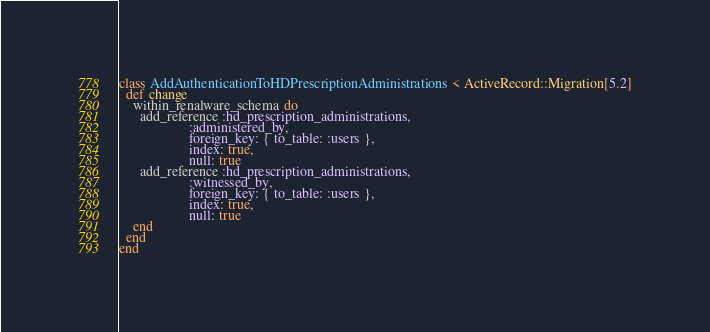<code> <loc_0><loc_0><loc_500><loc_500><_Ruby_>class AddAuthenticationToHDPrescriptionAdministrations < ActiveRecord::Migration[5.2]
  def change
    within_renalware_schema do
      add_reference :hd_prescription_administrations,
                    :administered_by,
                    foreign_key: { to_table: :users },
                    index: true,
                    null: true
      add_reference :hd_prescription_administrations,
                    :witnessed_by,
                    foreign_key: { to_table: :users },
                    index: true,
                    null: true
    end
  end
end
</code> 